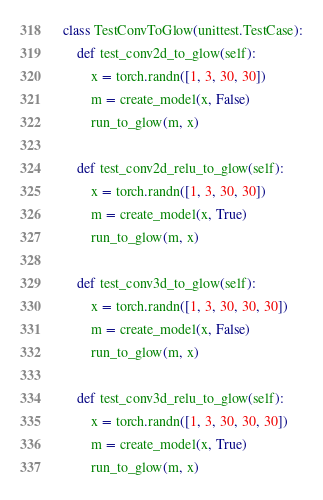Convert code to text. <code><loc_0><loc_0><loc_500><loc_500><_Python_>class TestConvToGlow(unittest.TestCase):
    def test_conv2d_to_glow(self):
        x = torch.randn([1, 3, 30, 30])
        m = create_model(x, False)
        run_to_glow(m, x)

    def test_conv2d_relu_to_glow(self):
        x = torch.randn([1, 3, 30, 30])
        m = create_model(x, True)
        run_to_glow(m, x)

    def test_conv3d_to_glow(self):
        x = torch.randn([1, 3, 30, 30, 30])
        m = create_model(x, False)
        run_to_glow(m, x)

    def test_conv3d_relu_to_glow(self):
        x = torch.randn([1, 3, 30, 30, 30])
        m = create_model(x, True)
        run_to_glow(m, x)
</code> 